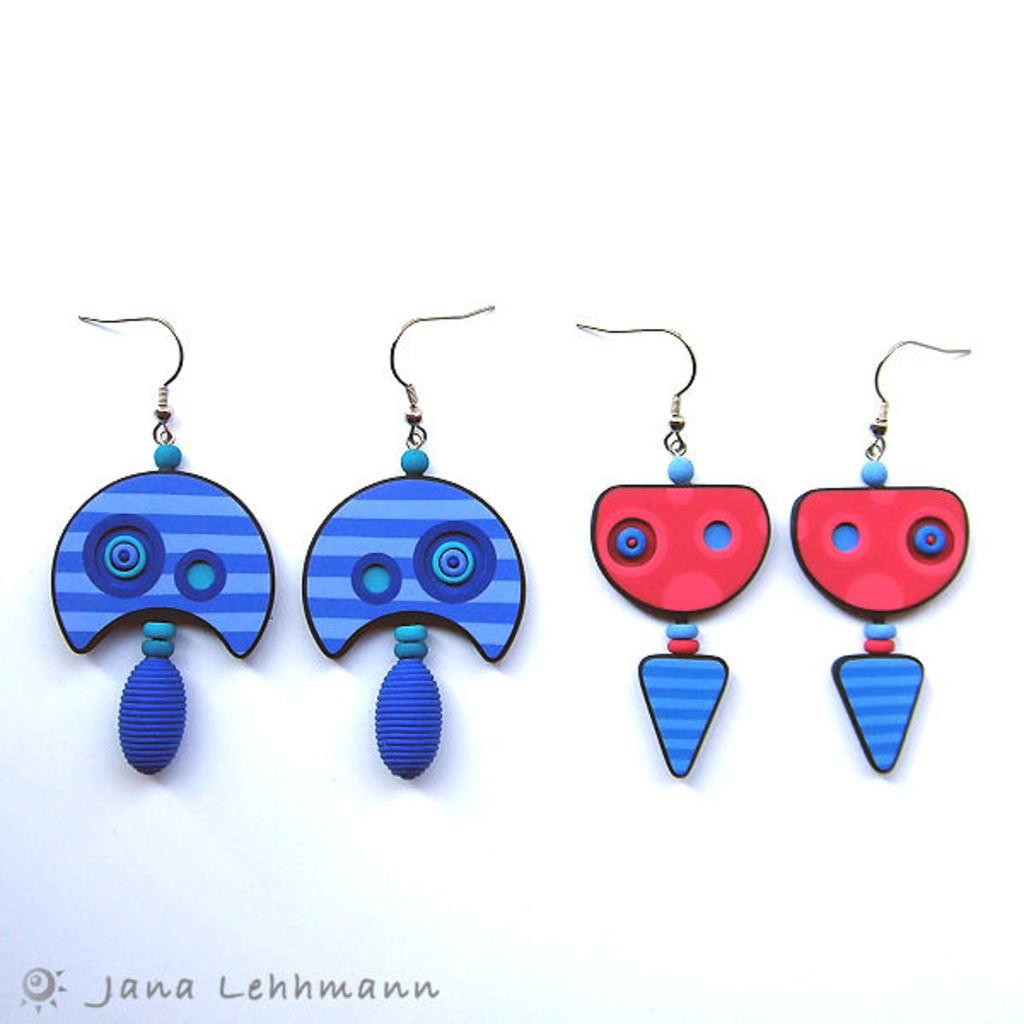What colors are the earrings on the left side of the image? The earrings on the left side are blue. What colors are the earrings on the right side of the image? The earrings on the right side are dark red. How many earrings are there in total in the image? There are four earrings in the image, two on each side. What theory is being discussed by the servant in the image? There is no servant or discussion of a theory present in the image; it only features earrings. 